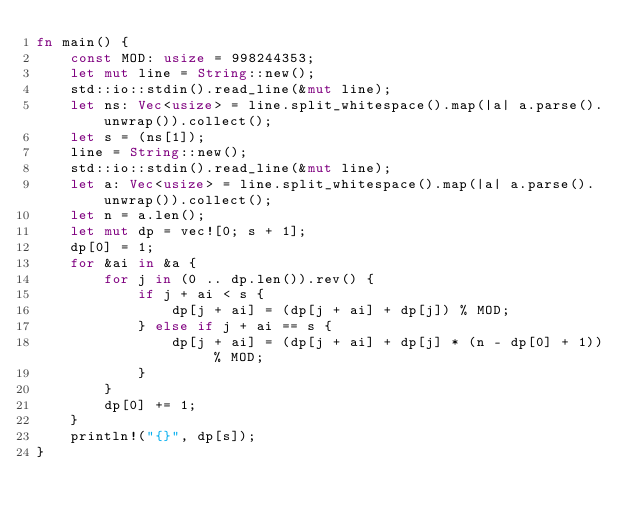Convert code to text. <code><loc_0><loc_0><loc_500><loc_500><_Rust_>fn main() {
    const MOD: usize = 998244353;
    let mut line = String::new();
    std::io::stdin().read_line(&mut line);
    let ns: Vec<usize> = line.split_whitespace().map(|a| a.parse().unwrap()).collect();
    let s = (ns[1]);
    line = String::new();
    std::io::stdin().read_line(&mut line);
    let a: Vec<usize> = line.split_whitespace().map(|a| a.parse().unwrap()).collect();
    let n = a.len();
    let mut dp = vec![0; s + 1];
    dp[0] = 1;
    for &ai in &a {
        for j in (0 .. dp.len()).rev() {
            if j + ai < s {
                dp[j + ai] = (dp[j + ai] + dp[j]) % MOD;
            } else if j + ai == s {
                dp[j + ai] = (dp[j + ai] + dp[j] * (n - dp[0] + 1)) % MOD;
            }
        }
        dp[0] += 1;
    }
    println!("{}", dp[s]);
}
</code> 